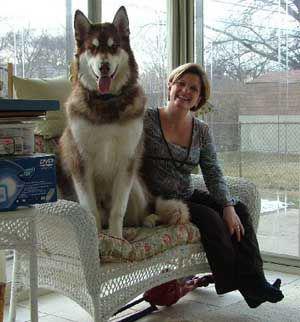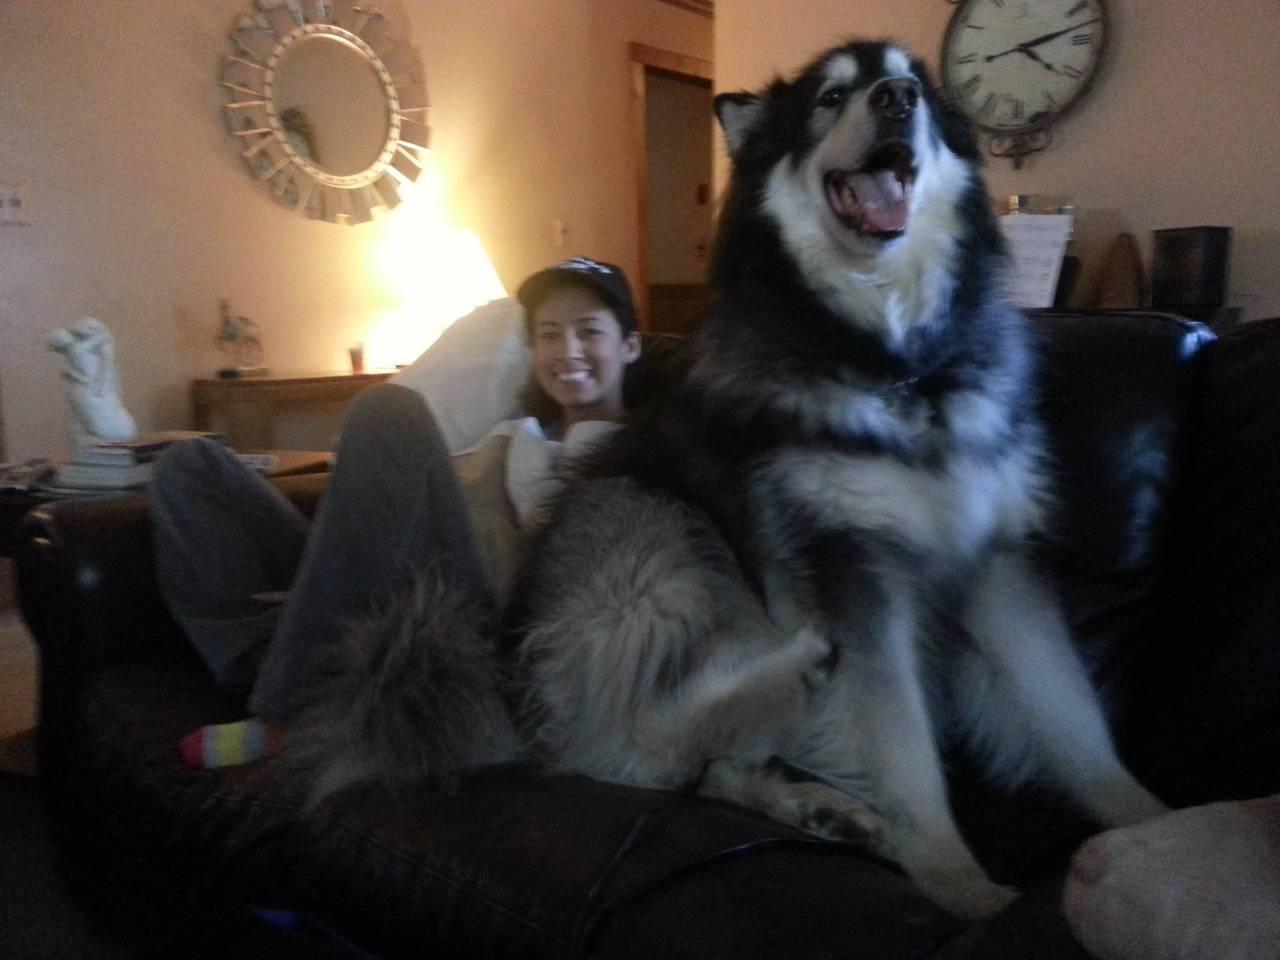The first image is the image on the left, the second image is the image on the right. Analyze the images presented: Is the assertion "Each image includes at least one person sitting close to at least one dog in an indoor setting, and the right image shows dog and human on a sofa." valid? Answer yes or no. Yes. The first image is the image on the left, the second image is the image on the right. Examine the images to the left and right. Is the description "There are more dogs in the image on the right." accurate? Answer yes or no. No. 